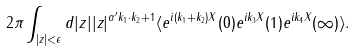<formula> <loc_0><loc_0><loc_500><loc_500>2 \pi \int _ { | z | < \epsilon } d | z | | z | ^ { \alpha ^ { \prime } k _ { 1 } \cdot k _ { 2 } + 1 } \langle e ^ { i ( k _ { 1 } + k _ { 2 } ) X } ( 0 ) e ^ { i k _ { 3 } X } ( 1 ) e ^ { i k _ { 4 } X } ( \infty ) \rangle .</formula> 